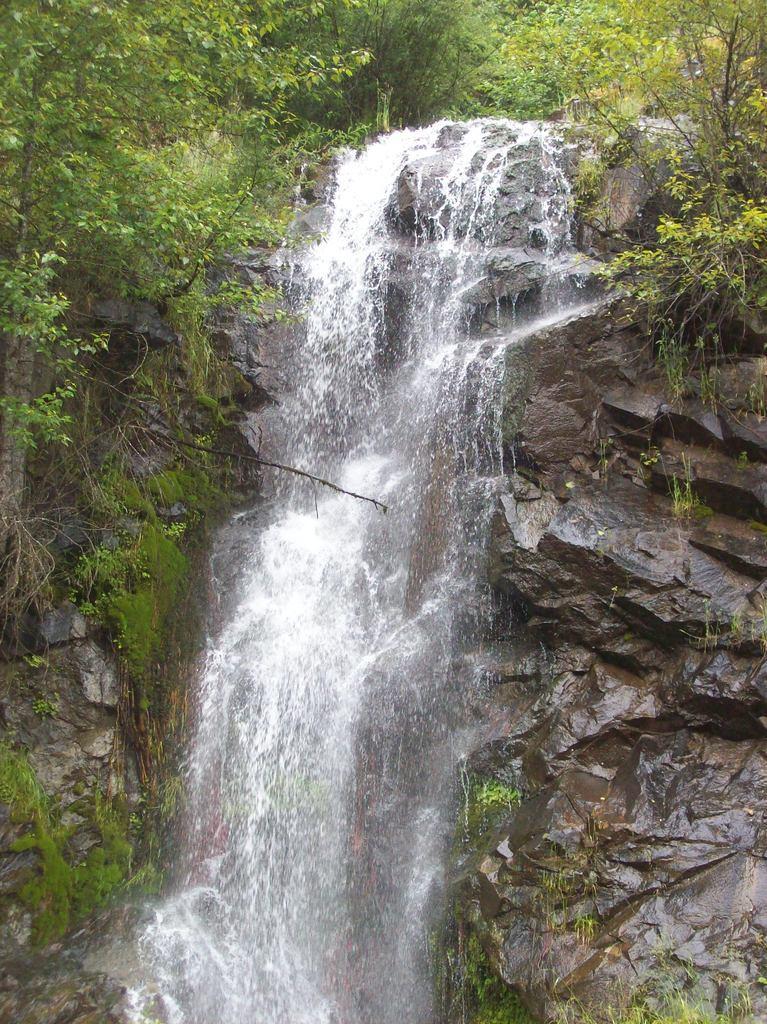Can you describe this image briefly? In this picture we can see rocks, water and in the background we can see trees. 